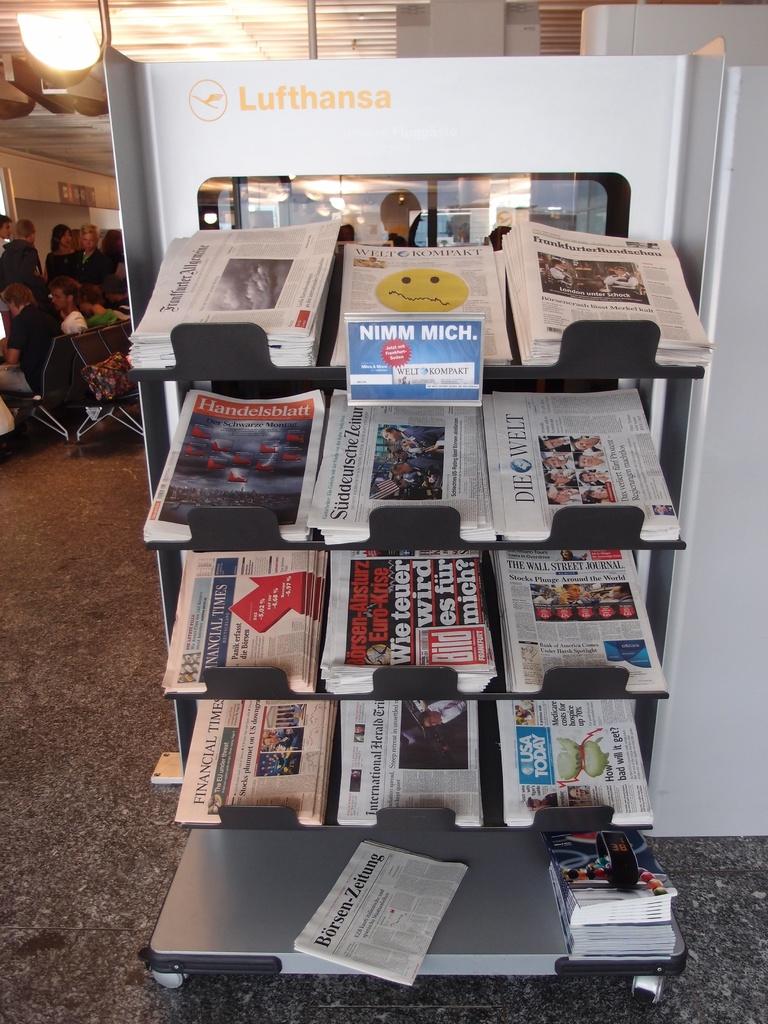What company is shown behind the magazine stand?
Ensure brevity in your answer.  Lufthansa. What is the name of the paper on the bottom shelf far right?
Your response must be concise. Usa today. 